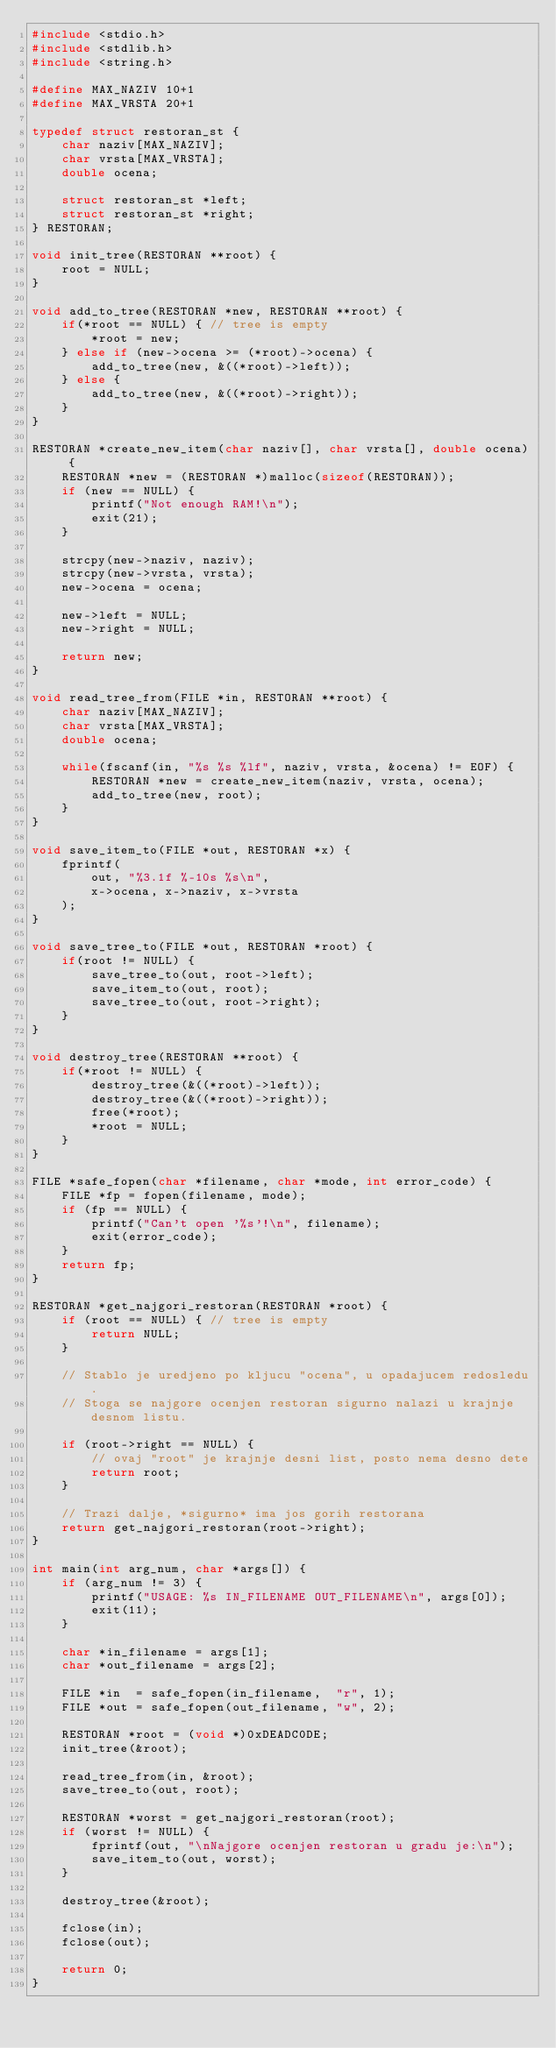Convert code to text. <code><loc_0><loc_0><loc_500><loc_500><_C_>#include <stdio.h>
#include <stdlib.h>
#include <string.h>

#define MAX_NAZIV 10+1
#define MAX_VRSTA 20+1

typedef struct restoran_st {
    char naziv[MAX_NAZIV];
    char vrsta[MAX_VRSTA];
    double ocena;

    struct restoran_st *left;
    struct restoran_st *right;
} RESTORAN;

void init_tree(RESTORAN **root) {
    root = NULL;
}

void add_to_tree(RESTORAN *new, RESTORAN **root) {
    if(*root == NULL) { // tree is empty
        *root = new;
    } else if (new->ocena >= (*root)->ocena) {
        add_to_tree(new, &((*root)->left));
    } else {
        add_to_tree(new, &((*root)->right));
    }
}

RESTORAN *create_new_item(char naziv[], char vrsta[], double ocena) {
    RESTORAN *new = (RESTORAN *)malloc(sizeof(RESTORAN));
    if (new == NULL) {
        printf("Not enough RAM!\n");
        exit(21);
    }

    strcpy(new->naziv, naziv);
    strcpy(new->vrsta, vrsta);
    new->ocena = ocena;

    new->left = NULL;
    new->right = NULL;

    return new;
}

void read_tree_from(FILE *in, RESTORAN **root) {
    char naziv[MAX_NAZIV];
    char vrsta[MAX_VRSTA];
    double ocena;

    while(fscanf(in, "%s %s %lf", naziv, vrsta, &ocena) != EOF) {
        RESTORAN *new = create_new_item(naziv, vrsta, ocena);
        add_to_tree(new, root);
    }
}

void save_item_to(FILE *out, RESTORAN *x) {
    fprintf(
        out, "%3.1f %-10s %s\n",
        x->ocena, x->naziv, x->vrsta
    );
}

void save_tree_to(FILE *out, RESTORAN *root) {
    if(root != NULL) {
        save_tree_to(out, root->left);
        save_item_to(out, root);
        save_tree_to(out, root->right);
    }
}

void destroy_tree(RESTORAN **root) {
    if(*root != NULL) {
        destroy_tree(&((*root)->left));
        destroy_tree(&((*root)->right));
        free(*root);
        *root = NULL;
    }
}

FILE *safe_fopen(char *filename, char *mode, int error_code) {
    FILE *fp = fopen(filename, mode);
    if (fp == NULL) {
        printf("Can't open '%s'!\n", filename);
        exit(error_code);
    }
    return fp;
}

RESTORAN *get_najgori_restoran(RESTORAN *root) {
    if (root == NULL) { // tree is empty
        return NULL;
    }

    // Stablo je uredjeno po kljucu "ocena", u opadajucem redosledu.
    // Stoga se najgore ocenjen restoran sigurno nalazi u krajnje desnom listu.

    if (root->right == NULL) {
        // ovaj "root" je krajnje desni list, posto nema desno dete
        return root;
    }

    // Trazi dalje, *sigurno* ima jos gorih restorana
    return get_najgori_restoran(root->right);
}

int main(int arg_num, char *args[]) {
    if (arg_num != 3) {
        printf("USAGE: %s IN_FILENAME OUT_FILENAME\n", args[0]);
        exit(11);
    }

    char *in_filename = args[1];
    char *out_filename = args[2];

    FILE *in  = safe_fopen(in_filename,  "r", 1);
    FILE *out = safe_fopen(out_filename, "w", 2);

    RESTORAN *root = (void *)0xDEADC0DE;
    init_tree(&root);

    read_tree_from(in, &root);
    save_tree_to(out, root);

    RESTORAN *worst = get_najgori_restoran(root);
    if (worst != NULL) {
        fprintf(out, "\nNajgore ocenjen restoran u gradu je:\n");
        save_item_to(out, worst);
    }

    destroy_tree(&root);

    fclose(in);
    fclose(out);

    return 0;
}
</code> 